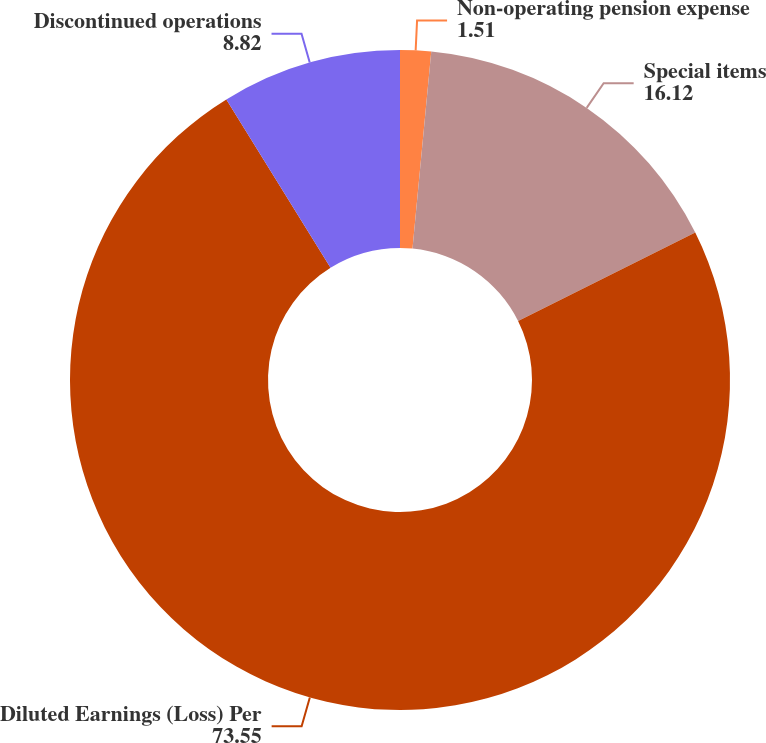Convert chart. <chart><loc_0><loc_0><loc_500><loc_500><pie_chart><fcel>Non-operating pension expense<fcel>Special items<fcel>Diluted Earnings (Loss) Per<fcel>Discontinued operations<nl><fcel>1.51%<fcel>16.12%<fcel>73.55%<fcel>8.82%<nl></chart> 